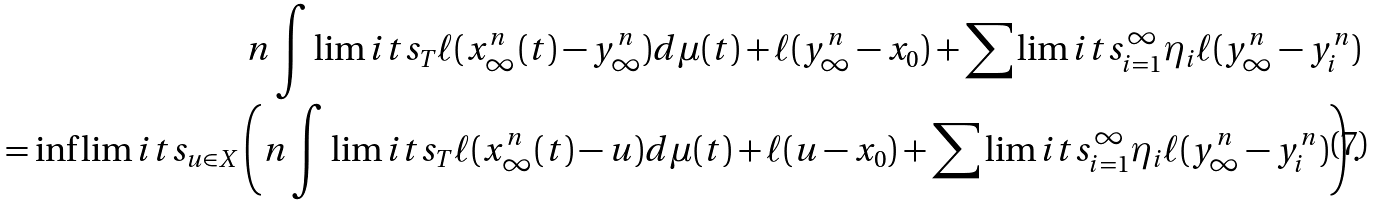<formula> <loc_0><loc_0><loc_500><loc_500>n \int \lim i t s _ { T } \ell ( x _ { \infty } ^ { n } ( t ) - y ^ { n } _ { \infty } ) d \mu ( t ) + \ell ( y _ { \infty } ^ { n } - x _ { 0 } ) + \sum \lim i t s _ { i = 1 } ^ { \infty } \eta _ { i } \ell ( y _ { \infty } ^ { n } - y ^ { n } _ { i } ) \\ = \inf \lim i t s _ { u \in X } \left ( n \int \lim i t s _ { T } \ell ( x _ { \infty } ^ { n } ( t ) - u ) d \mu ( t ) + \ell ( u - x _ { 0 } ) + \sum \lim i t s _ { i = 1 } ^ { \infty } \eta _ { i } \ell ( y _ { \infty } ^ { n } - y ^ { n } _ { i } ) \right ) .</formula> 